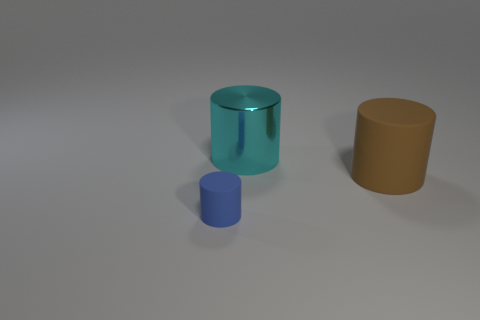Is there a small purple metal thing?
Ensure brevity in your answer.  No. How many other things are the same size as the brown matte thing?
Your answer should be compact. 1. Does the rubber cylinder to the left of the big matte object have the same color as the large cylinder right of the cyan metallic thing?
Give a very brief answer. No. There is a metallic thing that is the same shape as the tiny matte thing; what is its size?
Ensure brevity in your answer.  Large. Does the large thing behind the big brown matte cylinder have the same material as the object in front of the big brown matte thing?
Your response must be concise. No. What number of metal things are either small blue cylinders or tiny cyan cylinders?
Make the answer very short. 0. There is a cylinder that is on the left side of the large object that is behind the matte object that is right of the small matte thing; what is its material?
Your answer should be compact. Rubber. Is the shape of the rubber thing that is behind the small blue matte object the same as the matte object to the left of the big cyan object?
Provide a short and direct response. Yes. What color is the object that is behind the large cylinder that is right of the cyan metal cylinder?
Provide a short and direct response. Cyan. What number of cylinders are matte things or small brown things?
Offer a very short reply. 2. 